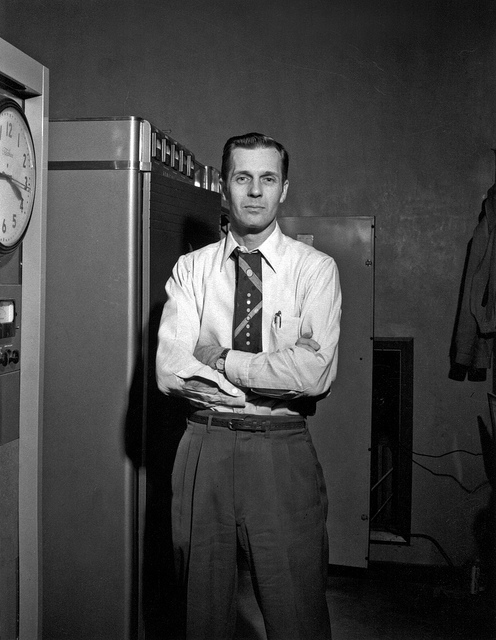Please identify all text content in this image. 12 2 6 